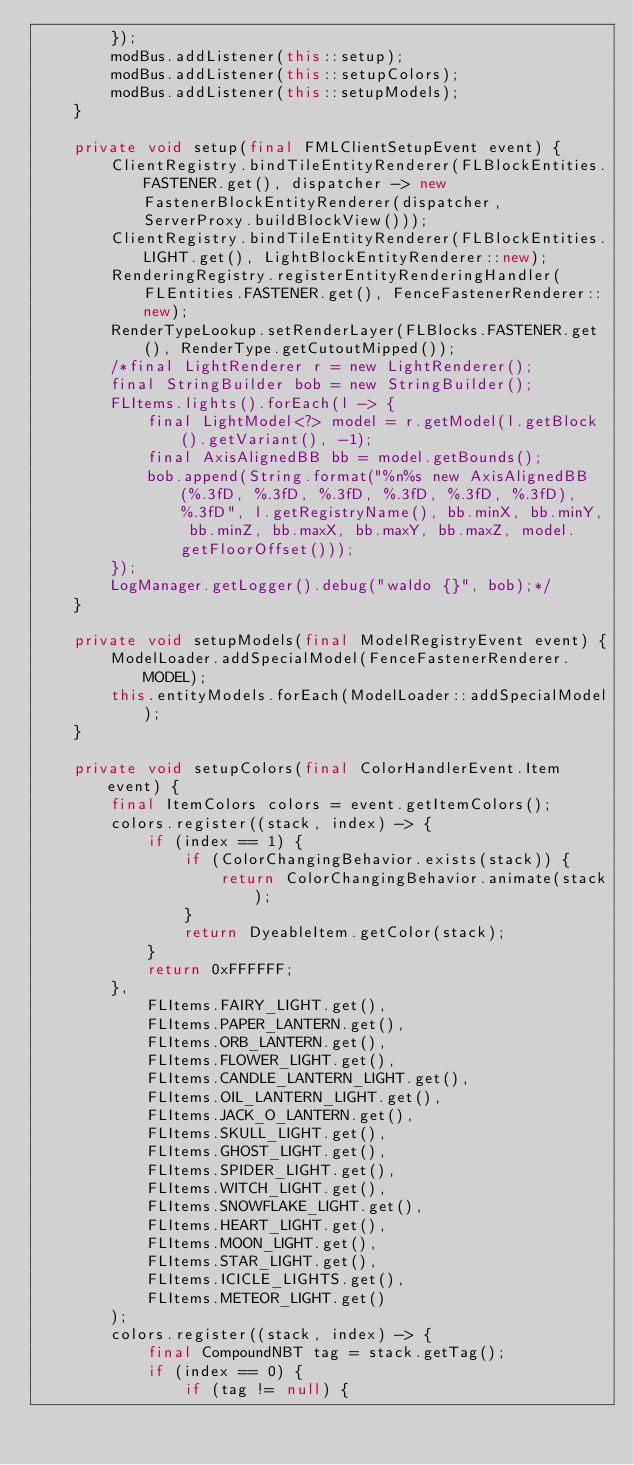<code> <loc_0><loc_0><loc_500><loc_500><_Java_>        });
        modBus.addListener(this::setup);
        modBus.addListener(this::setupColors);
        modBus.addListener(this::setupModels);
    }

    private void setup(final FMLClientSetupEvent event) {
        ClientRegistry.bindTileEntityRenderer(FLBlockEntities.FASTENER.get(), dispatcher -> new FastenerBlockEntityRenderer(dispatcher, ServerProxy.buildBlockView()));
        ClientRegistry.bindTileEntityRenderer(FLBlockEntities.LIGHT.get(), LightBlockEntityRenderer::new);
        RenderingRegistry.registerEntityRenderingHandler(FLEntities.FASTENER.get(), FenceFastenerRenderer::new);
        RenderTypeLookup.setRenderLayer(FLBlocks.FASTENER.get(), RenderType.getCutoutMipped());
        /*final LightRenderer r = new LightRenderer();
        final StringBuilder bob = new StringBuilder();
        FLItems.lights().forEach(l -> {
            final LightModel<?> model = r.getModel(l.getBlock().getVariant(), -1);
            final AxisAlignedBB bb = model.getBounds();
            bob.append(String.format("%n%s new AxisAlignedBB(%.3fD, %.3fD, %.3fD, %.3fD, %.3fD, %.3fD), %.3fD", l.getRegistryName(), bb.minX, bb.minY, bb.minZ, bb.maxX, bb.maxY, bb.maxZ, model.getFloorOffset()));
        });
        LogManager.getLogger().debug("waldo {}", bob);*/
    }

    private void setupModels(final ModelRegistryEvent event) {
        ModelLoader.addSpecialModel(FenceFastenerRenderer.MODEL);
        this.entityModels.forEach(ModelLoader::addSpecialModel);
    }

    private void setupColors(final ColorHandlerEvent.Item event) {
        final ItemColors colors = event.getItemColors();
        colors.register((stack, index) -> {
            if (index == 1) {
                if (ColorChangingBehavior.exists(stack)) {
                    return ColorChangingBehavior.animate(stack);
                }
                return DyeableItem.getColor(stack);
            }
            return 0xFFFFFF;
        },
            FLItems.FAIRY_LIGHT.get(),
            FLItems.PAPER_LANTERN.get(),
            FLItems.ORB_LANTERN.get(),
            FLItems.FLOWER_LIGHT.get(),
            FLItems.CANDLE_LANTERN_LIGHT.get(),
            FLItems.OIL_LANTERN_LIGHT.get(),
            FLItems.JACK_O_LANTERN.get(),
            FLItems.SKULL_LIGHT.get(),
            FLItems.GHOST_LIGHT.get(),
            FLItems.SPIDER_LIGHT.get(),
            FLItems.WITCH_LIGHT.get(),
            FLItems.SNOWFLAKE_LIGHT.get(),
            FLItems.HEART_LIGHT.get(),
            FLItems.MOON_LIGHT.get(),
            FLItems.STAR_LIGHT.get(),
            FLItems.ICICLE_LIGHTS.get(),
            FLItems.METEOR_LIGHT.get()
        );
        colors.register((stack, index) -> {
            final CompoundNBT tag = stack.getTag();
            if (index == 0) {
                if (tag != null) {</code> 